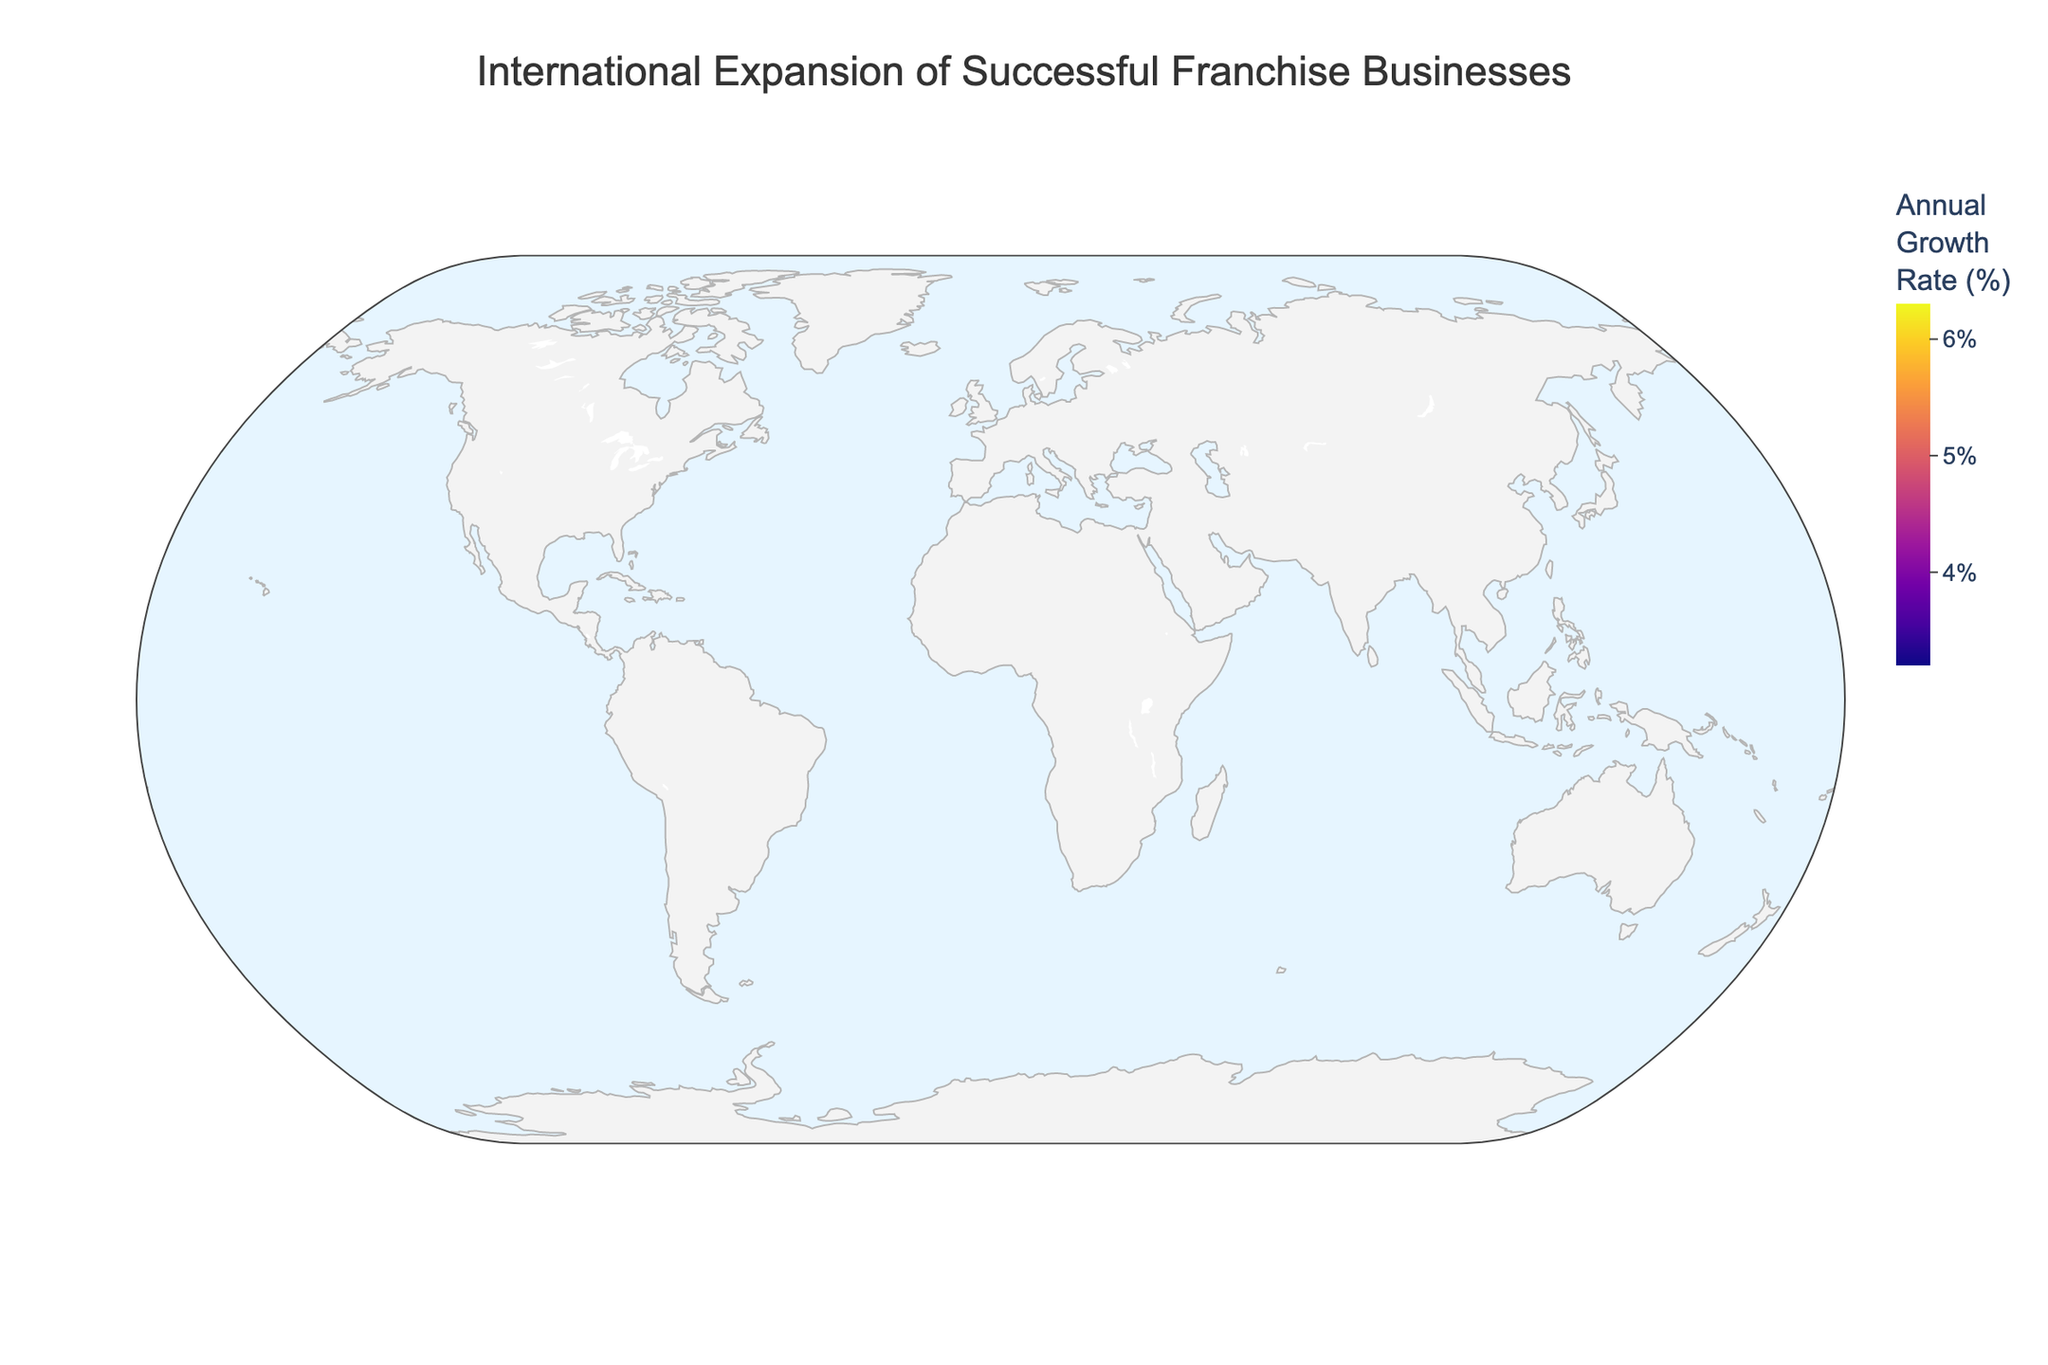What is the title of this geographic plot? The title is written at the top center of the plot, providing an overview of what the plot represents. It reads "International Expansion of Successful Franchise Businesses."
Answer: International Expansion of Successful Franchise Businesses Which franchise has the highest annual growth rate in the figure? By observing the color and size of the markers in the plot, the franchise with the highest annual growth rate is 7-Eleven. This is shown in the Asia-Pacific region by the largest and darkest marker.
Answer: 7-Eleven What is the annual growth rate of Starbucks in Oceania? Hovering over the marker for Oceania or observing the text display reveals that Starbucks has an annual growth rate of 4.1%.
Answer: 4.1% How many regions have an annual growth rate higher than 5%? By visually scanning the plot and counting, we find that Asia-Pacific (7-Eleven: 5.7%), Latin America (Domino's Pizza: 6.3%), and Southeast Asia (Pizza Hut: 5.2%) have growth rates higher than 5%.
Answer: 3 Which franchise in South Asia has an annual growth rate of 4.7%? By looking at the marker for South Asia, the text display shows that Taco Bell is the franchise with a 4.7% annual growth rate.
Answer: Taco Bell What is the difference in annual growth rate between the franchises in North America and Africa? North America (McDonald's) has an annual growth rate of 4.2%, and Africa (Burger King) has an annual growth rate of 3.5%. The difference is calculated as 4.2% - 3.5% = 0.7%.
Answer: 0.7% Which has a higher annual growth rate: Dunkin' Donuts in Eastern Europe or Subway in Europe? By comparing the markers, Dunkin' Donuts in Eastern Europe shows an annual growth rate of 3.9%, whereas Subway in Europe has a growth rate of 3.8%. Dunkin' Donuts has a higher growth rate.
Answer: Dunkin' Donuts What is the mean annual growth rate of the franchises represented in North America, Europe, and Oceania? North America (McDonald's: 4.2%), Europe (Subway: 3.8%), and Oceania (Starbucks: 4.1%). To find the mean: (4.2 + 3.8 + 4.1) / 3 = 4.03%.
Answer: 4.03% Identify the region with the lowest annual growth rate and name the corresponding franchise. The marker for Nordic Countries represents the lowest growth rate of 3.2%, which corresponds to Avis.
Answer: Nordic Countries, Avis 